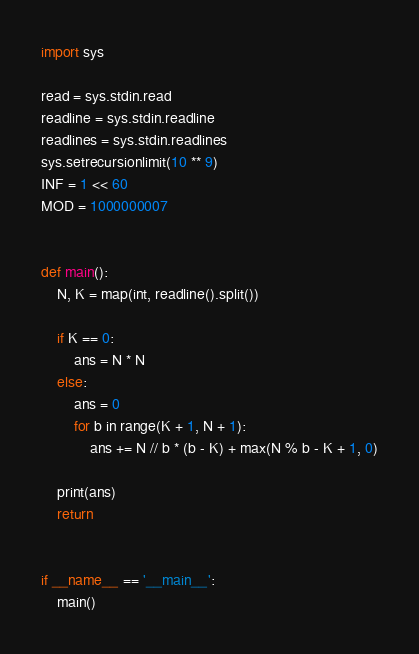<code> <loc_0><loc_0><loc_500><loc_500><_Python_>import sys

read = sys.stdin.read
readline = sys.stdin.readline
readlines = sys.stdin.readlines
sys.setrecursionlimit(10 ** 9)
INF = 1 << 60
MOD = 1000000007


def main():
    N, K = map(int, readline().split())

    if K == 0:
        ans = N * N
    else:
        ans = 0
        for b in range(K + 1, N + 1):
            ans += N // b * (b - K) + max(N % b - K + 1, 0)

    print(ans)
    return


if __name__ == '__main__':
    main()
</code> 